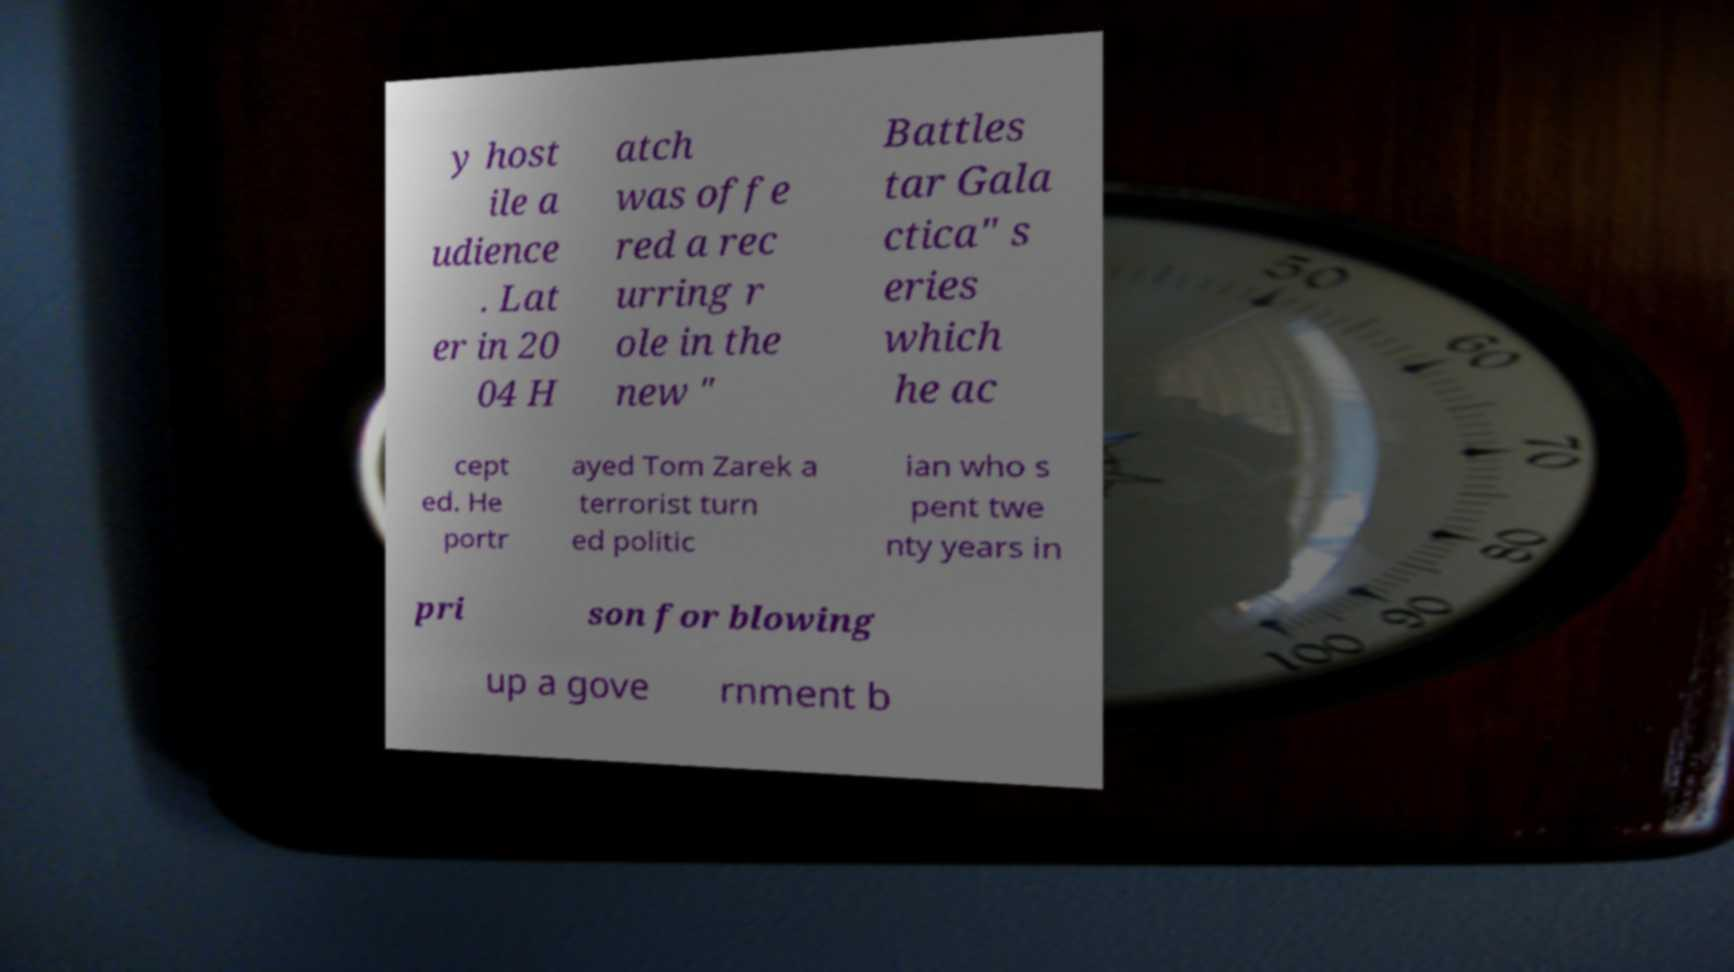I need the written content from this picture converted into text. Can you do that? y host ile a udience . Lat er in 20 04 H atch was offe red a rec urring r ole in the new " Battles tar Gala ctica" s eries which he ac cept ed. He portr ayed Tom Zarek a terrorist turn ed politic ian who s pent twe nty years in pri son for blowing up a gove rnment b 